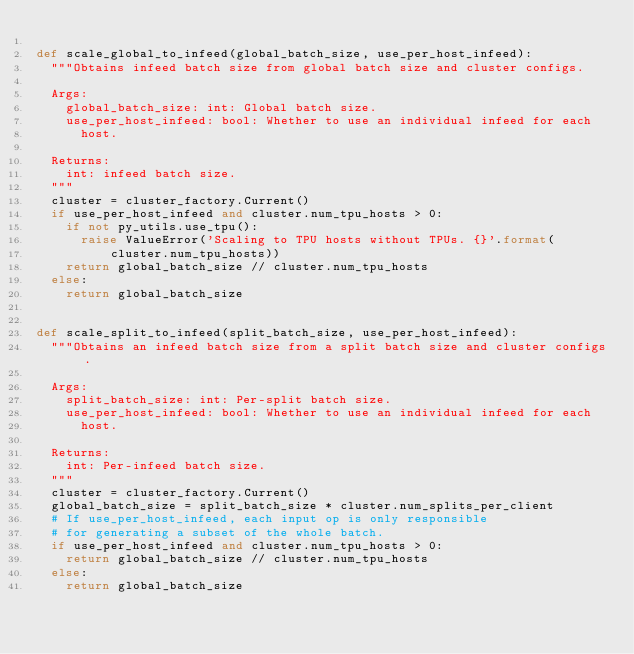Convert code to text. <code><loc_0><loc_0><loc_500><loc_500><_Python_>
def scale_global_to_infeed(global_batch_size, use_per_host_infeed):
  """Obtains infeed batch size from global batch size and cluster configs.

  Args:
    global_batch_size: int: Global batch size.
    use_per_host_infeed: bool: Whether to use an individual infeed for each
      host.

  Returns:
    int: infeed batch size.
  """
  cluster = cluster_factory.Current()
  if use_per_host_infeed and cluster.num_tpu_hosts > 0:
    if not py_utils.use_tpu():
      raise ValueError('Scaling to TPU hosts without TPUs. {}'.format(
          cluster.num_tpu_hosts))
    return global_batch_size // cluster.num_tpu_hosts
  else:
    return global_batch_size


def scale_split_to_infeed(split_batch_size, use_per_host_infeed):
  """Obtains an infeed batch size from a split batch size and cluster configs.

  Args:
    split_batch_size: int: Per-split batch size.
    use_per_host_infeed: bool: Whether to use an individual infeed for each
      host.

  Returns:
    int: Per-infeed batch size.
  """
  cluster = cluster_factory.Current()
  global_batch_size = split_batch_size * cluster.num_splits_per_client
  # If use_per_host_infeed, each input op is only responsible
  # for generating a subset of the whole batch.
  if use_per_host_infeed and cluster.num_tpu_hosts > 0:
    return global_batch_size // cluster.num_tpu_hosts
  else:
    return global_batch_size
</code> 